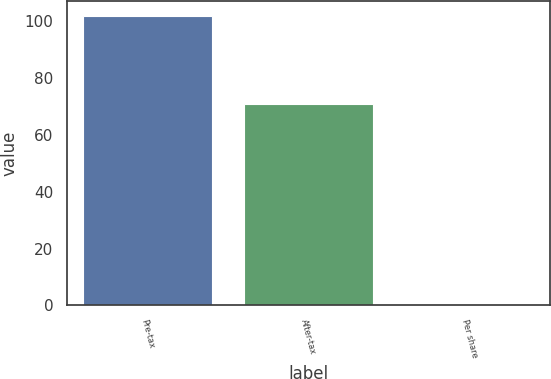Convert chart to OTSL. <chart><loc_0><loc_0><loc_500><loc_500><bar_chart><fcel>Pre-tax<fcel>After-tax<fcel>Per share<nl><fcel>102<fcel>71<fcel>0.04<nl></chart> 